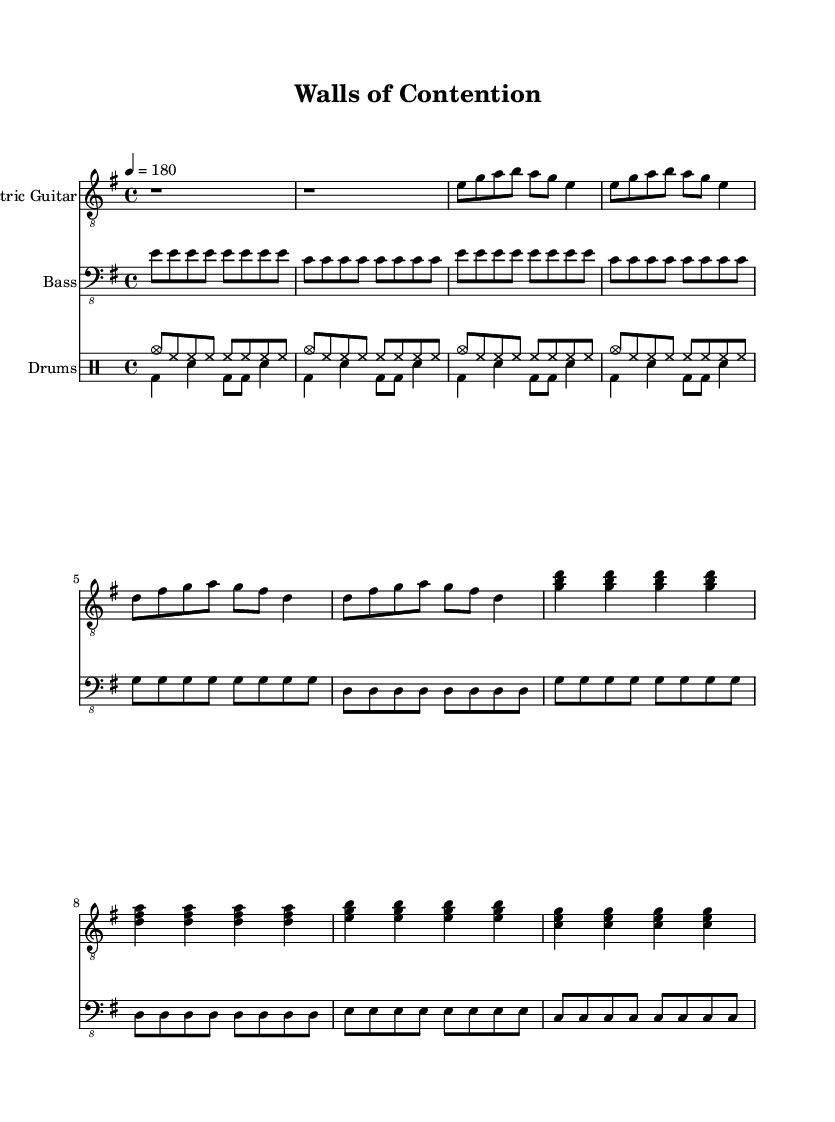What is the key signature of this music? The key signature is E minor, which has one sharp (F#). This is determined by looking at the key indicated at the beginning of the piece.
Answer: E minor What is the time signature of this music? The time signature is 4/4, which means there are four beats in each measure and the quarter note gets one beat. It is clearly indicated at the beginning of the music.
Answer: 4/4 What is the tempo marking of the piece? The tempo marking is 180 beats per minute. This is specified at the start of the piece with the tempo indication, suggesting a fast pace.
Answer: 180 How many measures are in the verse section? There are eight measures in the verse section. By counting the measures visually represented in the verse from the sheet music, you can find the total.
Answer: 8 What is the primary instrument in this punk piece? The primary instrument is the Electric Guitar, as it is the first staff listed in the score and is typical for punk rock music.
Answer: Electric Guitar What type of musical rhythm predominates in this punk piece? The predominant rhythm is a fast, driving eighth note rhythm. This is observed from the frequent use of eighth notes in both guitar and bass parts, creating a sense of urgency typical of punk music.
Answer: Fast eighth notes Which chords are indicated in the chorus? The chords in the chorus are G major, D major, E minor, and C major. These are shown in the chord notation above the staff, defining the harmonic structure for that section.
Answer: G, D, E, C 